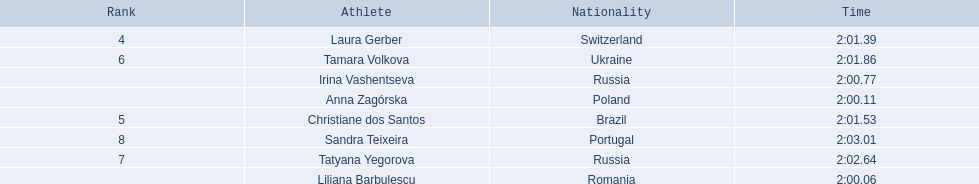What athletes are in the top five for the women's 800 metres? Liliana Barbulescu, Anna Zagórska, Irina Vashentseva, Laura Gerber, Christiane dos Santos. Which athletes are in the top 3? Liliana Barbulescu, Anna Zagórska, Irina Vashentseva. Who is the second place runner in the women's 800 metres? Anna Zagórska. What is the second place runner's time? 2:00.11. 